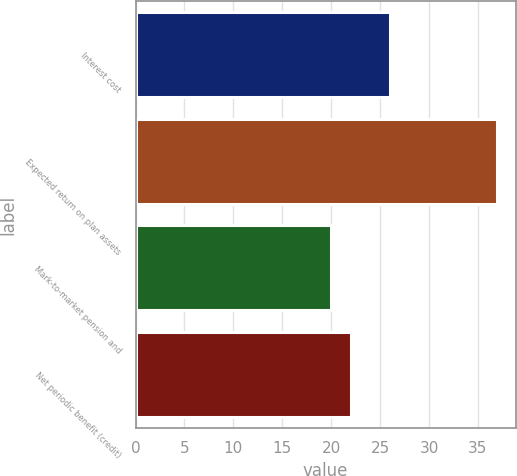Convert chart. <chart><loc_0><loc_0><loc_500><loc_500><bar_chart><fcel>Interest cost<fcel>Expected return on plan assets<fcel>Mark-to-market pension and<fcel>Net periodic benefit (credit)<nl><fcel>26<fcel>37<fcel>20<fcel>22<nl></chart> 